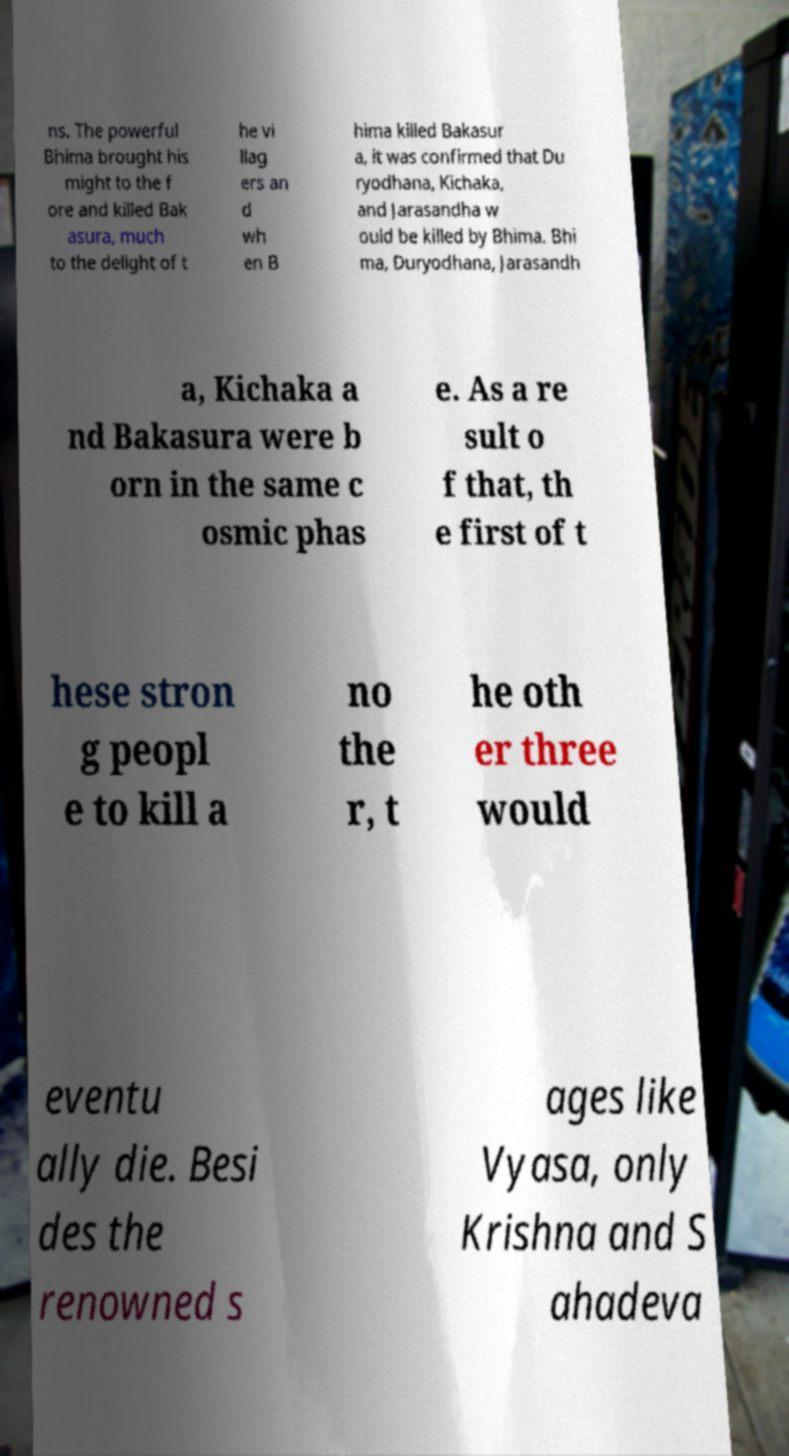Could you extract and type out the text from this image? ns. The powerful Bhima brought his might to the f ore and killed Bak asura, much to the delight of t he vi llag ers an d wh en B hima killed Bakasur a, it was confirmed that Du ryodhana, Kichaka, and Jarasandha w ould be killed by Bhima. Bhi ma, Duryodhana, Jarasandh a, Kichaka a nd Bakasura were b orn in the same c osmic phas e. As a re sult o f that, th e first of t hese stron g peopl e to kill a no the r, t he oth er three would eventu ally die. Besi des the renowned s ages like Vyasa, only Krishna and S ahadeva 